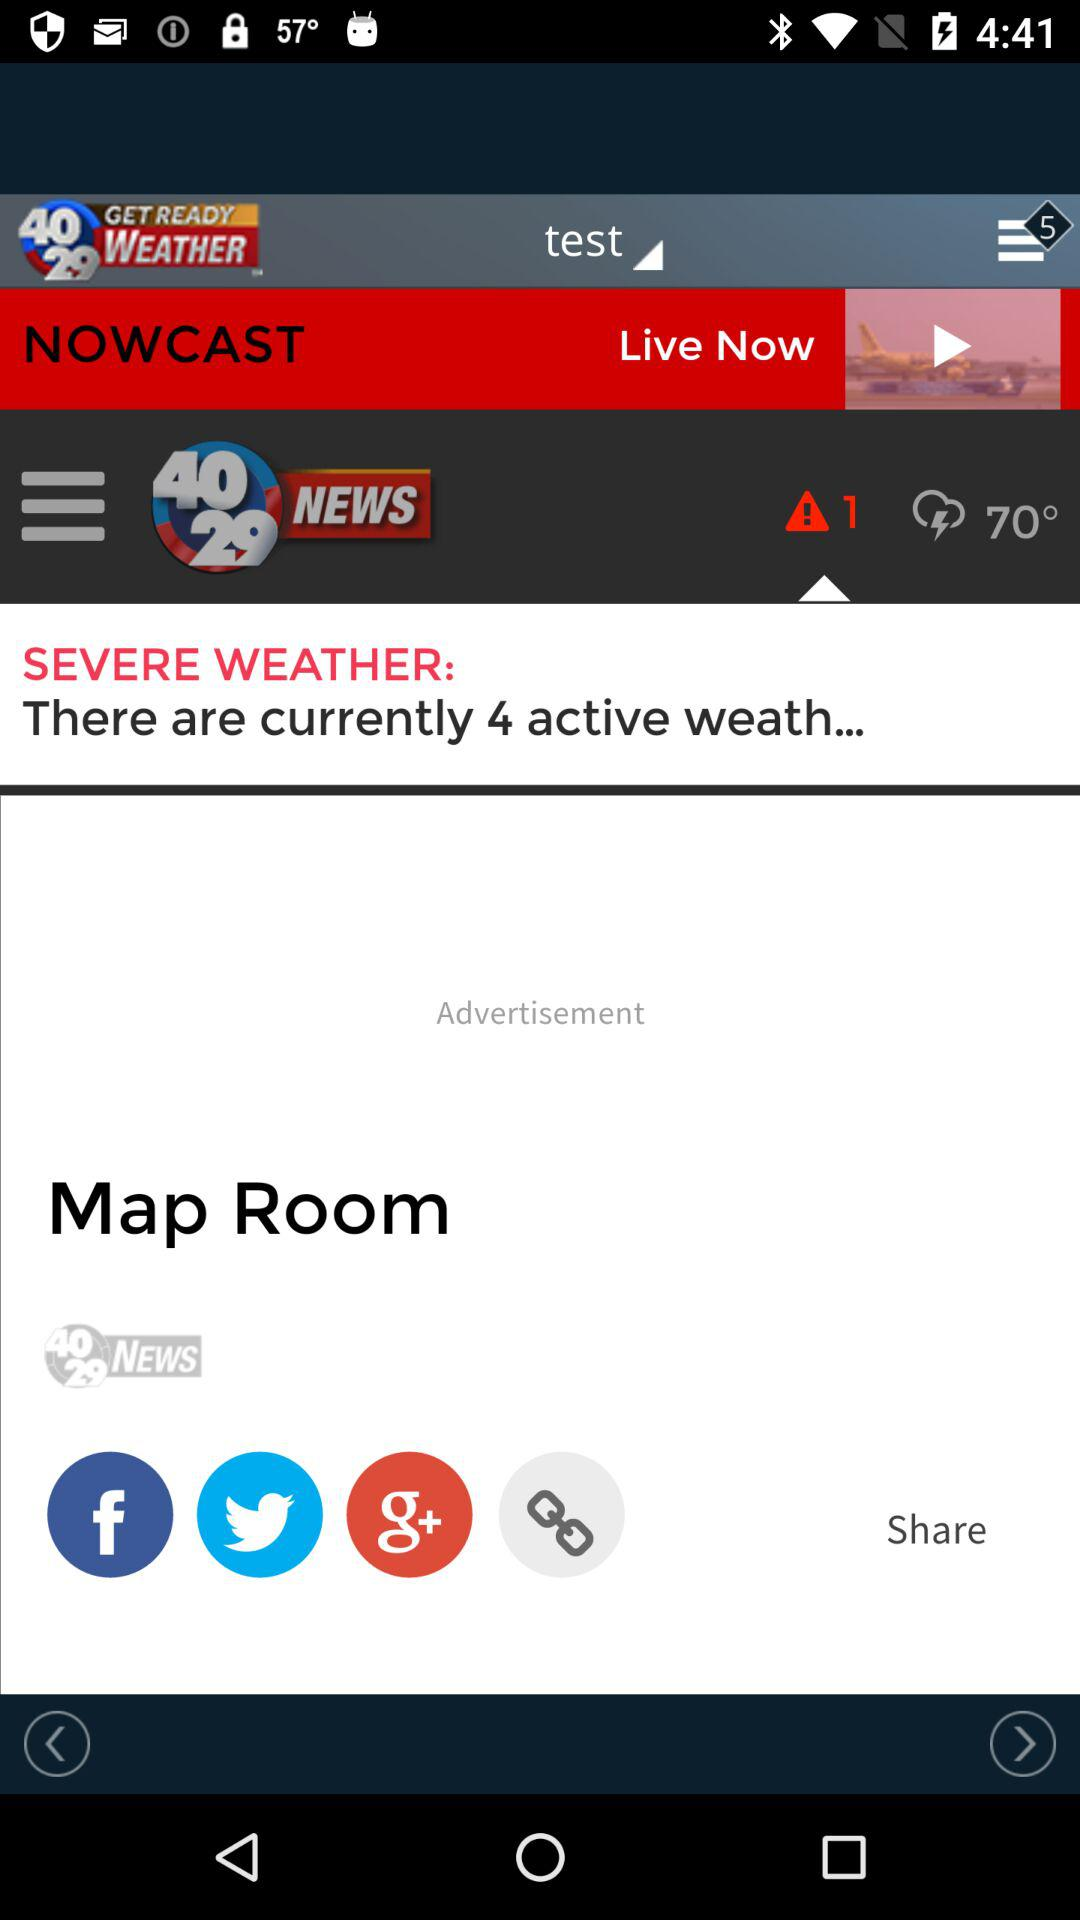What is the application name? The application name is "40/29 NEWS". 